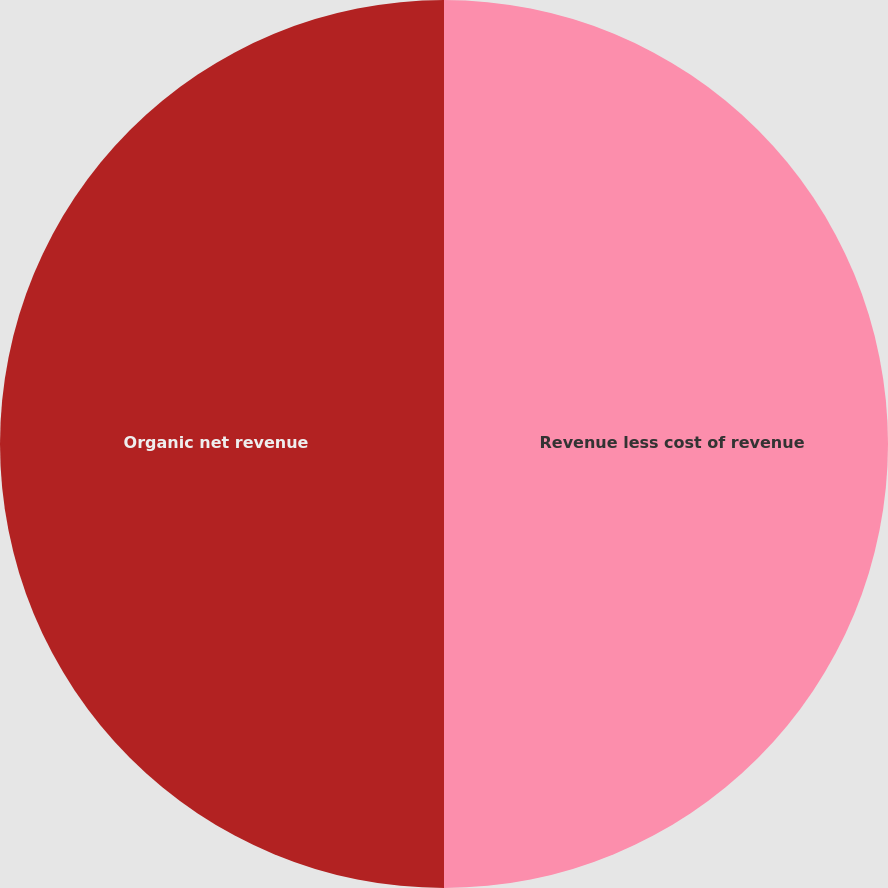Convert chart to OTSL. <chart><loc_0><loc_0><loc_500><loc_500><pie_chart><fcel>Revenue less cost of revenue<fcel>Organic net revenue<nl><fcel>50.0%<fcel>50.0%<nl></chart> 